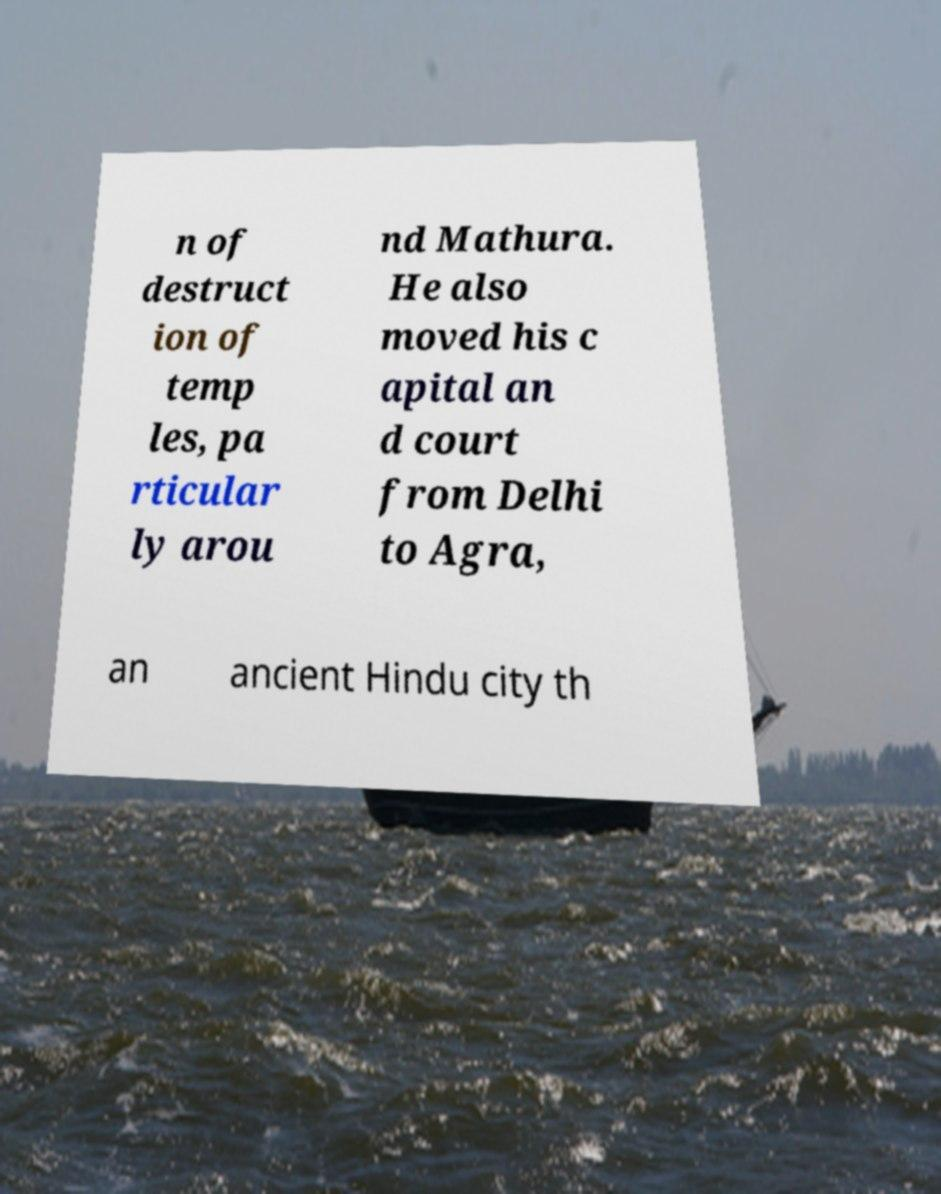Can you accurately transcribe the text from the provided image for me? n of destruct ion of temp les, pa rticular ly arou nd Mathura. He also moved his c apital an d court from Delhi to Agra, an ancient Hindu city th 